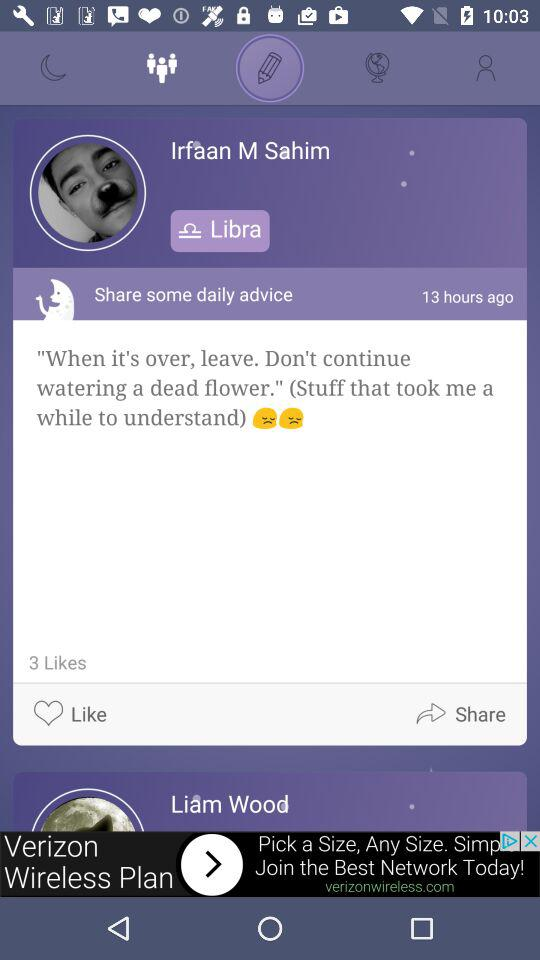What's the name of the person? The names of the people are Irfaan M. Sahim and Liam Wood. 